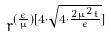<formula> <loc_0><loc_0><loc_500><loc_500>r ^ { ( \frac { \epsilon } { \mu } ) [ 4 \cdot \sqrt { 4 \cdot \frac { 2 \mu ^ { 2 } t } { \epsilon } } ] }</formula> 